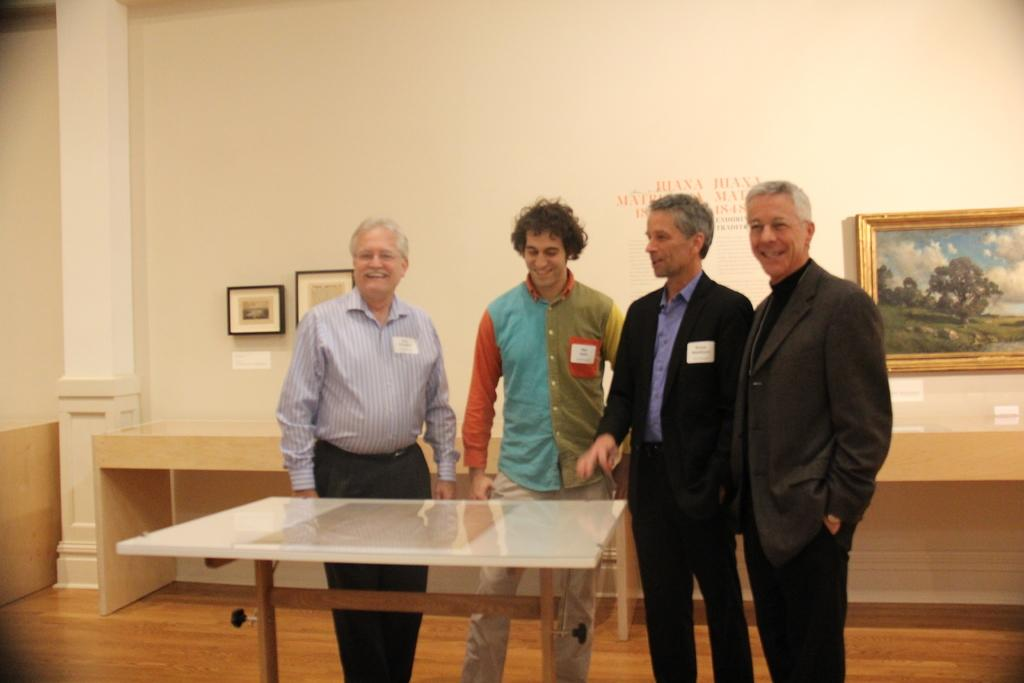What is the color of the wall in the image? The wall in the image is white. What is hanging on the wall? There are photo frames on the wall. How many people are in the image? There are four people standing in the image. What is in front of the people? There is a table in front of the people. What type of baseball game is being played in the image? There is no baseball game present in the image. What religious symbols can be seen in the image? There are no religious symbols present in the image. 